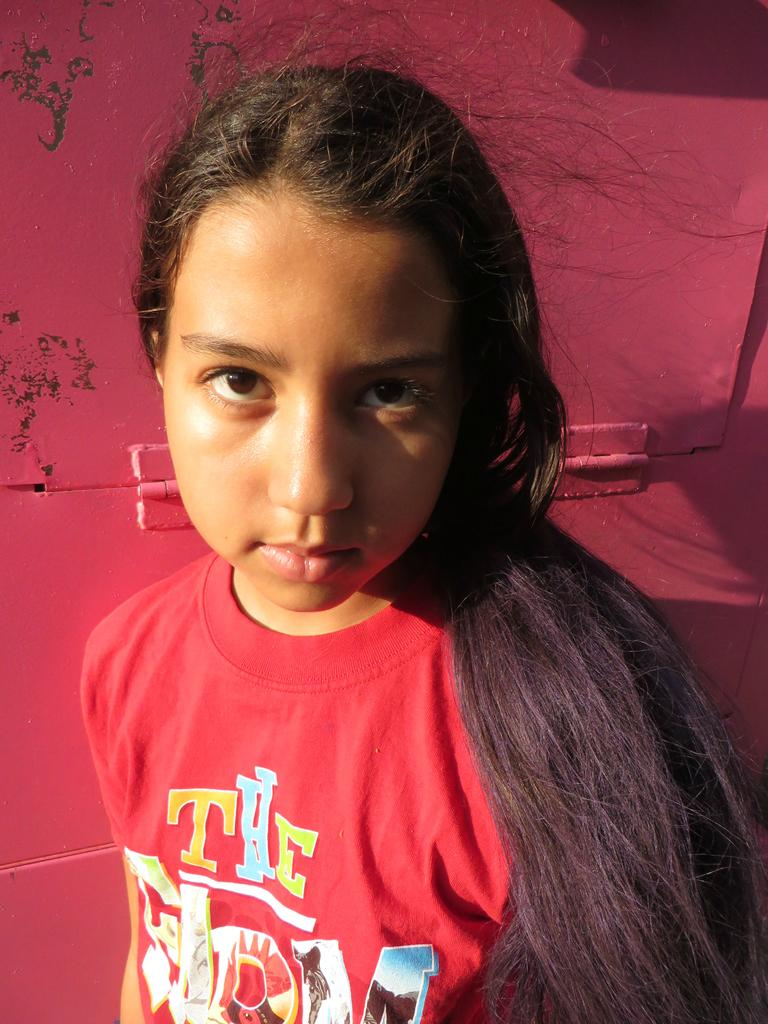Provide a one-sentence caption for the provided image. A girl is wearing a red t-shirt and one of the words on it is "the". 